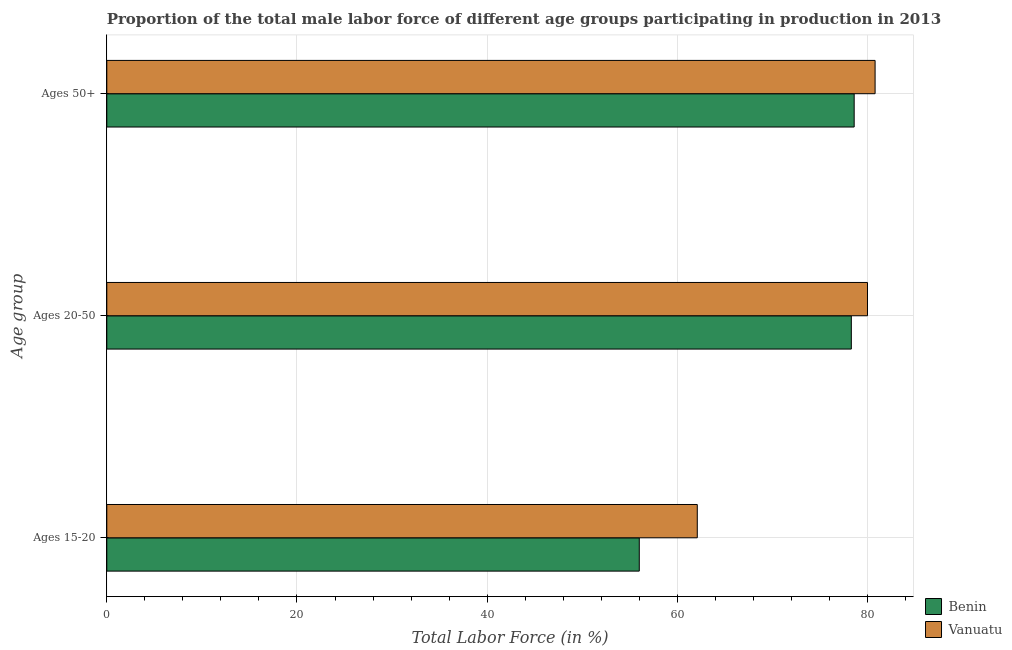How many groups of bars are there?
Make the answer very short. 3. Are the number of bars per tick equal to the number of legend labels?
Ensure brevity in your answer.  Yes. What is the label of the 2nd group of bars from the top?
Make the answer very short. Ages 20-50. What is the percentage of male labor force within the age group 15-20 in Benin?
Make the answer very short. 56. Across all countries, what is the minimum percentage of male labor force above age 50?
Make the answer very short. 78.6. In which country was the percentage of male labor force above age 50 maximum?
Your answer should be compact. Vanuatu. In which country was the percentage of male labor force within the age group 15-20 minimum?
Ensure brevity in your answer.  Benin. What is the total percentage of male labor force within the age group 20-50 in the graph?
Your response must be concise. 158.3. What is the difference between the percentage of male labor force above age 50 in Benin and that in Vanuatu?
Make the answer very short. -2.2. What is the difference between the percentage of male labor force within the age group 15-20 in Vanuatu and the percentage of male labor force above age 50 in Benin?
Your answer should be compact. -16.5. What is the average percentage of male labor force within the age group 20-50 per country?
Your response must be concise. 79.15. What is the difference between the percentage of male labor force within the age group 20-50 and percentage of male labor force within the age group 15-20 in Benin?
Give a very brief answer. 22.3. In how many countries, is the percentage of male labor force within the age group 15-20 greater than 44 %?
Your answer should be compact. 2. What is the ratio of the percentage of male labor force within the age group 15-20 in Benin to that in Vanuatu?
Give a very brief answer. 0.9. Is the percentage of male labor force above age 50 in Vanuatu less than that in Benin?
Your response must be concise. No. What is the difference between the highest and the second highest percentage of male labor force within the age group 20-50?
Give a very brief answer. 1.7. What is the difference between the highest and the lowest percentage of male labor force within the age group 15-20?
Keep it short and to the point. 6.1. In how many countries, is the percentage of male labor force above age 50 greater than the average percentage of male labor force above age 50 taken over all countries?
Your answer should be compact. 1. Is the sum of the percentage of male labor force within the age group 20-50 in Benin and Vanuatu greater than the maximum percentage of male labor force above age 50 across all countries?
Your answer should be compact. Yes. What does the 1st bar from the top in Ages 50+ represents?
Ensure brevity in your answer.  Vanuatu. What does the 1st bar from the bottom in Ages 20-50 represents?
Your answer should be very brief. Benin. Is it the case that in every country, the sum of the percentage of male labor force within the age group 15-20 and percentage of male labor force within the age group 20-50 is greater than the percentage of male labor force above age 50?
Provide a succinct answer. Yes. How many countries are there in the graph?
Provide a succinct answer. 2. Are the values on the major ticks of X-axis written in scientific E-notation?
Keep it short and to the point. No. Where does the legend appear in the graph?
Offer a terse response. Bottom right. How are the legend labels stacked?
Make the answer very short. Vertical. What is the title of the graph?
Provide a short and direct response. Proportion of the total male labor force of different age groups participating in production in 2013. What is the label or title of the Y-axis?
Your answer should be compact. Age group. What is the Total Labor Force (in %) in Benin in Ages 15-20?
Offer a very short reply. 56. What is the Total Labor Force (in %) in Vanuatu in Ages 15-20?
Offer a terse response. 62.1. What is the Total Labor Force (in %) in Benin in Ages 20-50?
Provide a short and direct response. 78.3. What is the Total Labor Force (in %) of Benin in Ages 50+?
Make the answer very short. 78.6. What is the Total Labor Force (in %) in Vanuatu in Ages 50+?
Your answer should be compact. 80.8. Across all Age group, what is the maximum Total Labor Force (in %) of Benin?
Your answer should be very brief. 78.6. Across all Age group, what is the maximum Total Labor Force (in %) of Vanuatu?
Keep it short and to the point. 80.8. Across all Age group, what is the minimum Total Labor Force (in %) in Benin?
Offer a terse response. 56. Across all Age group, what is the minimum Total Labor Force (in %) in Vanuatu?
Make the answer very short. 62.1. What is the total Total Labor Force (in %) in Benin in the graph?
Offer a terse response. 212.9. What is the total Total Labor Force (in %) of Vanuatu in the graph?
Keep it short and to the point. 222.9. What is the difference between the Total Labor Force (in %) of Benin in Ages 15-20 and that in Ages 20-50?
Provide a short and direct response. -22.3. What is the difference between the Total Labor Force (in %) in Vanuatu in Ages 15-20 and that in Ages 20-50?
Ensure brevity in your answer.  -17.9. What is the difference between the Total Labor Force (in %) of Benin in Ages 15-20 and that in Ages 50+?
Offer a terse response. -22.6. What is the difference between the Total Labor Force (in %) of Vanuatu in Ages 15-20 and that in Ages 50+?
Your response must be concise. -18.7. What is the difference between the Total Labor Force (in %) of Benin in Ages 20-50 and that in Ages 50+?
Make the answer very short. -0.3. What is the difference between the Total Labor Force (in %) in Benin in Ages 15-20 and the Total Labor Force (in %) in Vanuatu in Ages 20-50?
Keep it short and to the point. -24. What is the difference between the Total Labor Force (in %) of Benin in Ages 15-20 and the Total Labor Force (in %) of Vanuatu in Ages 50+?
Offer a terse response. -24.8. What is the difference between the Total Labor Force (in %) of Benin in Ages 20-50 and the Total Labor Force (in %) of Vanuatu in Ages 50+?
Provide a succinct answer. -2.5. What is the average Total Labor Force (in %) of Benin per Age group?
Ensure brevity in your answer.  70.97. What is the average Total Labor Force (in %) in Vanuatu per Age group?
Provide a succinct answer. 74.3. What is the difference between the Total Labor Force (in %) of Benin and Total Labor Force (in %) of Vanuatu in Ages 20-50?
Give a very brief answer. -1.7. What is the difference between the Total Labor Force (in %) in Benin and Total Labor Force (in %) in Vanuatu in Ages 50+?
Make the answer very short. -2.2. What is the ratio of the Total Labor Force (in %) in Benin in Ages 15-20 to that in Ages 20-50?
Keep it short and to the point. 0.72. What is the ratio of the Total Labor Force (in %) of Vanuatu in Ages 15-20 to that in Ages 20-50?
Provide a succinct answer. 0.78. What is the ratio of the Total Labor Force (in %) in Benin in Ages 15-20 to that in Ages 50+?
Provide a succinct answer. 0.71. What is the ratio of the Total Labor Force (in %) in Vanuatu in Ages 15-20 to that in Ages 50+?
Keep it short and to the point. 0.77. What is the ratio of the Total Labor Force (in %) of Benin in Ages 20-50 to that in Ages 50+?
Offer a terse response. 1. What is the ratio of the Total Labor Force (in %) of Vanuatu in Ages 20-50 to that in Ages 50+?
Provide a short and direct response. 0.99. What is the difference between the highest and the second highest Total Labor Force (in %) in Benin?
Keep it short and to the point. 0.3. What is the difference between the highest and the lowest Total Labor Force (in %) in Benin?
Offer a terse response. 22.6. What is the difference between the highest and the lowest Total Labor Force (in %) of Vanuatu?
Provide a short and direct response. 18.7. 